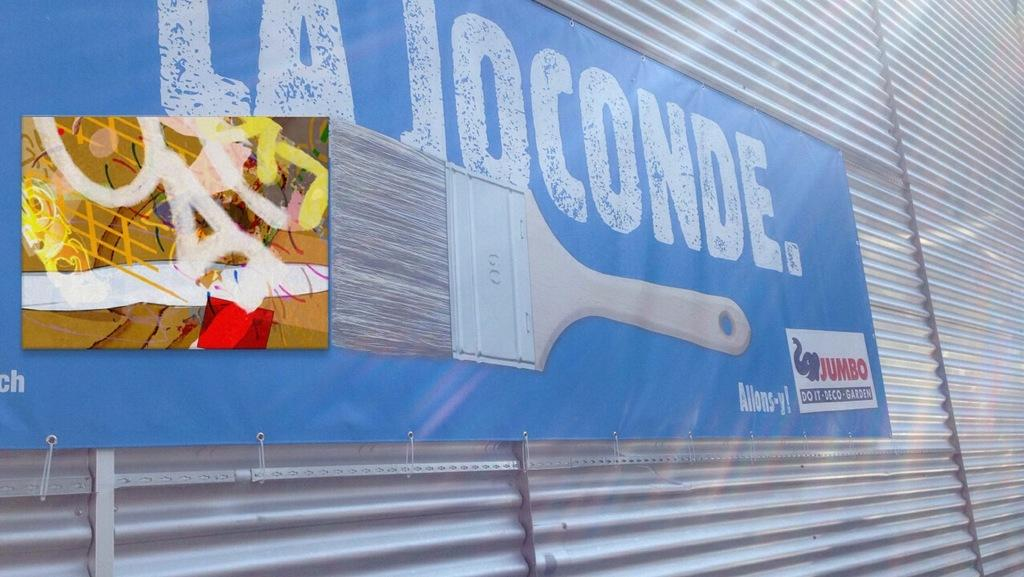Provide a one-sentence caption for the provided image. A blue sign that reads "la joconde" is on a corrugated wall siding. 